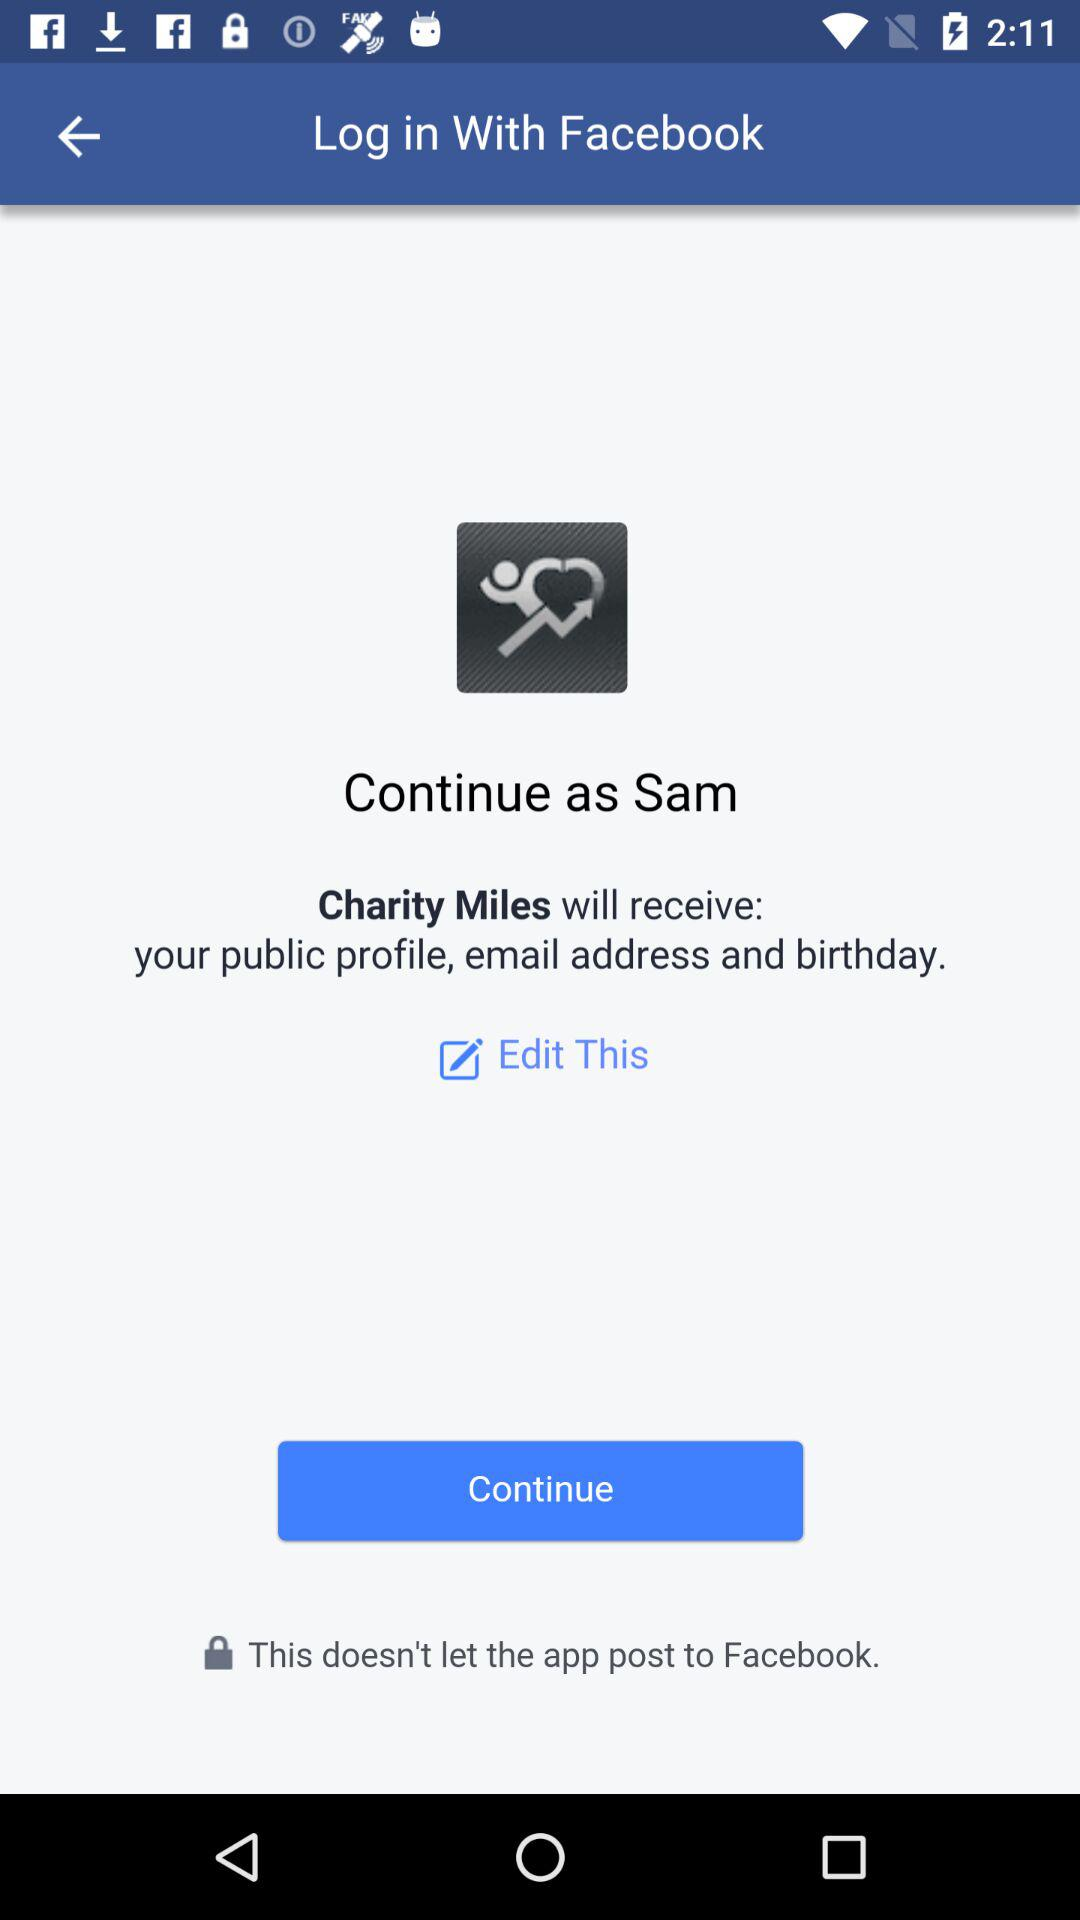What is the name of the user? The name of the user is Sam. 